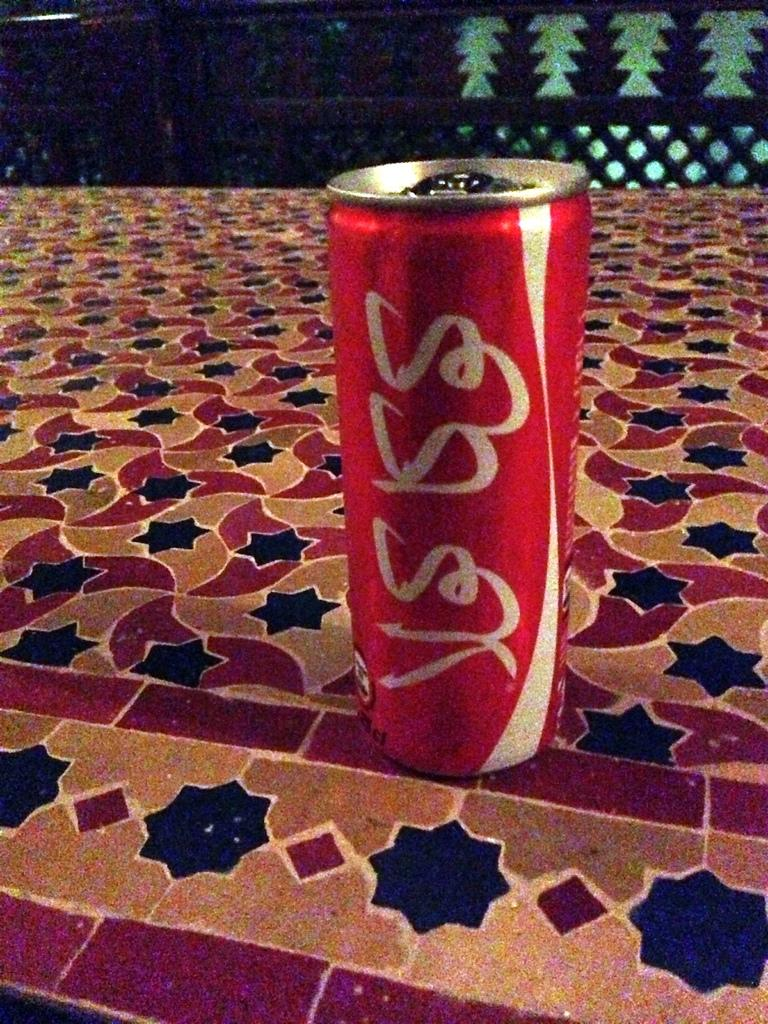<image>
Give a short and clear explanation of the subsequent image. A can of coke placed on some colorful tile. 